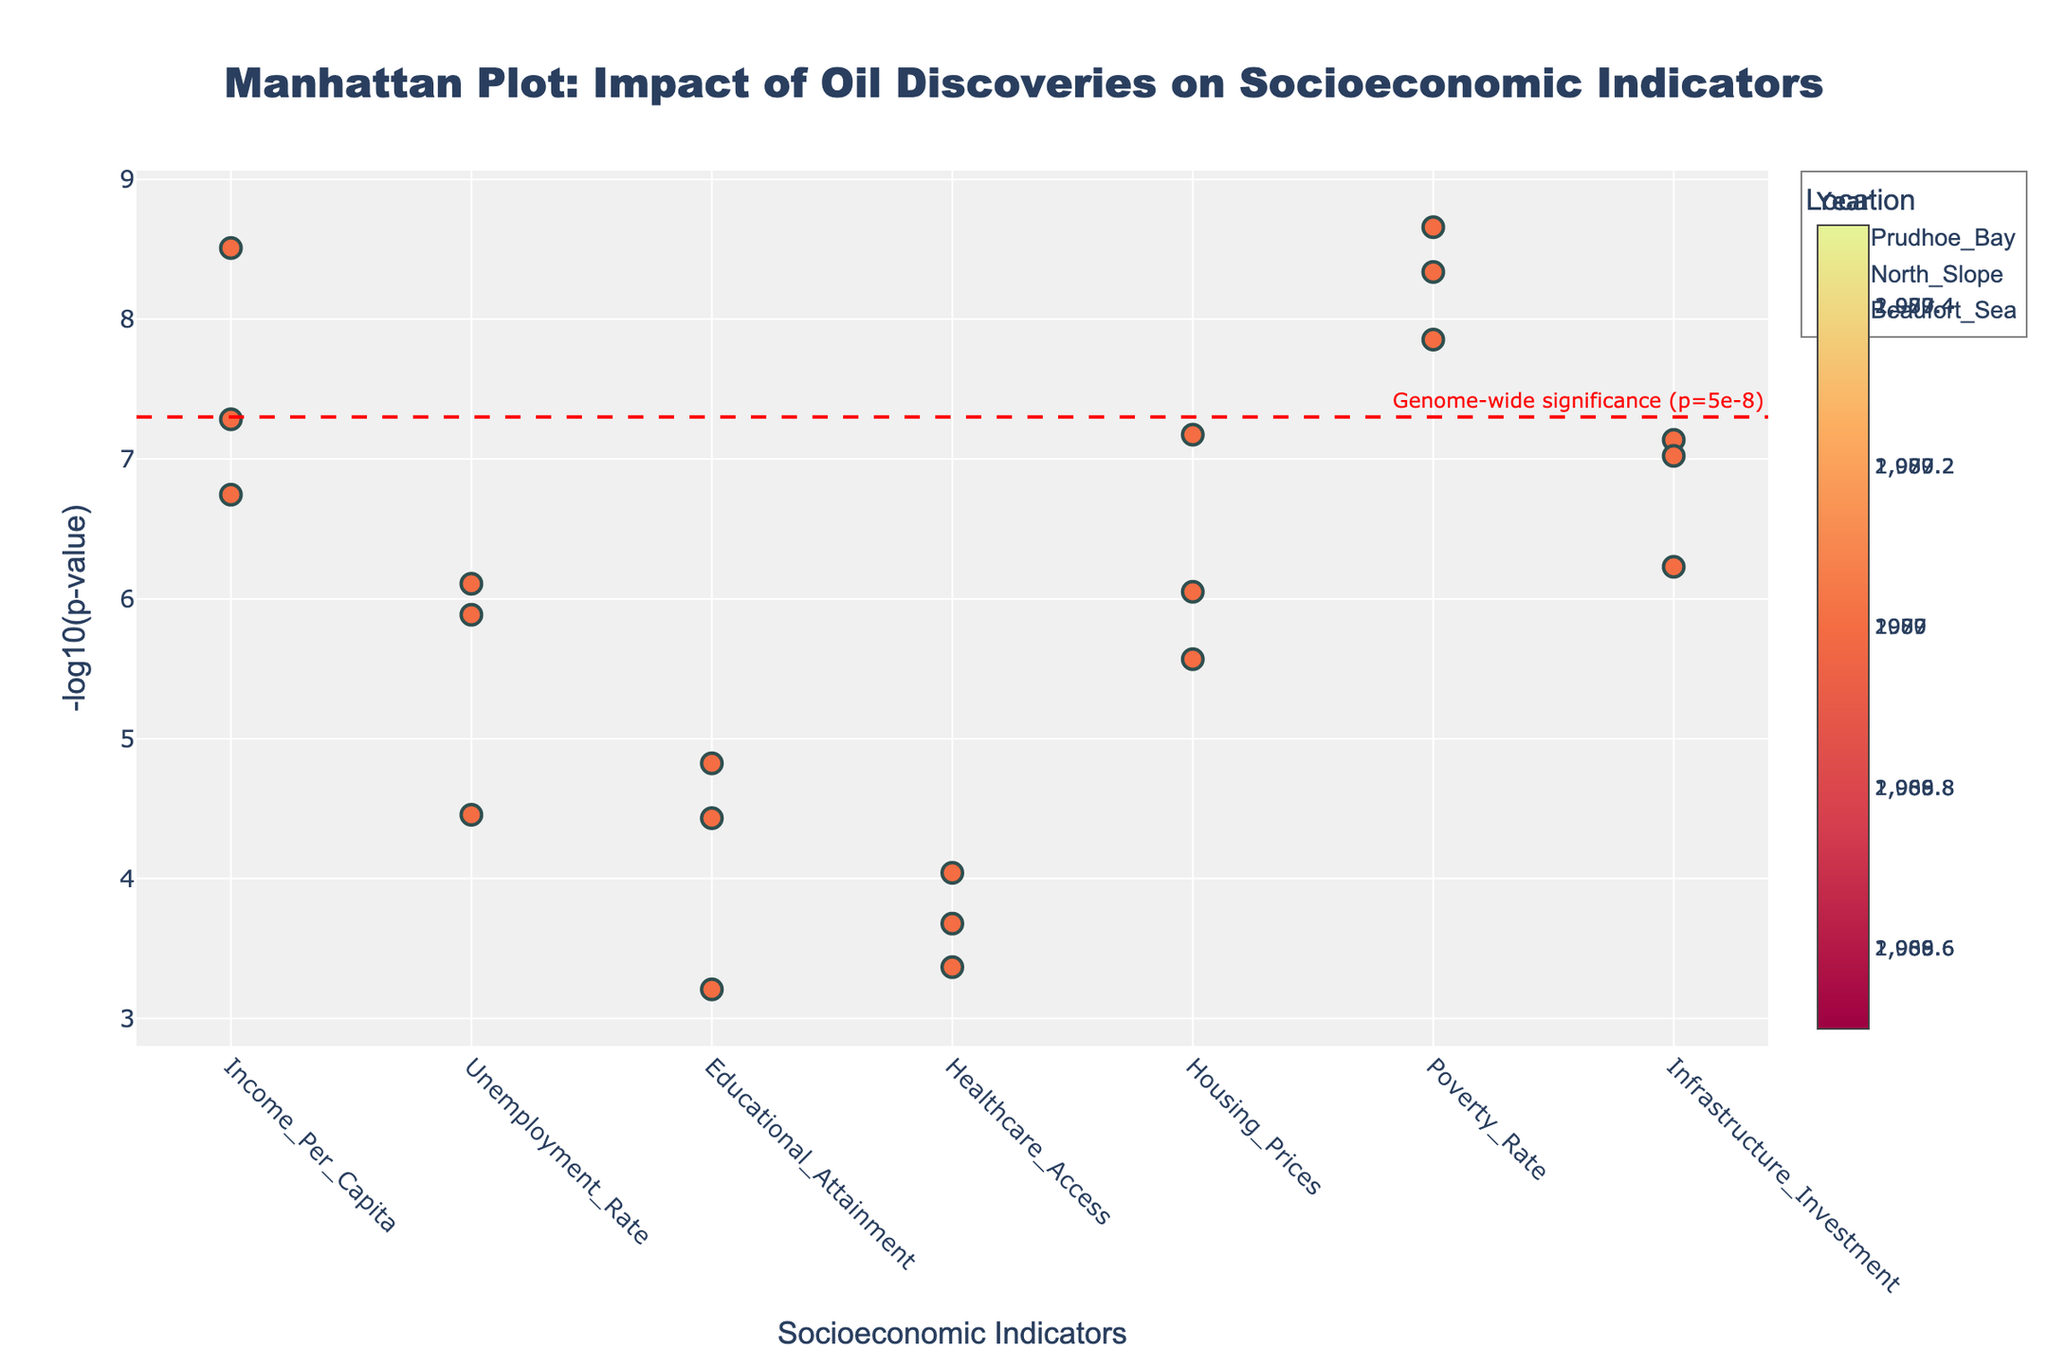What is the title of the plot? The title is displayed at the top of the plot. It reads "Manhattan Plot: Impact of Oil Discoveries on Socioeconomic Indicators."
Answer: Manhattan Plot: Impact of Oil Discoveries on Socioeconomic Indicators What are the x-axis and y-axis labels of the plot? The x-axis and y-axis labels are displayed along their respective axes. The x-axis is labeled "Socioeconomic Indicators," and the y-axis is labeled "-log10(p-value)."
Answer: Socioeconomic Indicators; -log10(p-value) What is the significance of the horizontal red dashed line in the plot? The horizontal red dashed line represents the genome-wide significance threshold, which is at -log10(p-value) for a p-value of 5e-8. This line is annotated with the text "Genome-wide significance (p=5e-8)."
Answer: Genome-wide significance (p=5e-8) Which socioeconomic indicator has the most significant p-value in 2007 at the Beaufort Sea? The most significant p-value corresponds to the highest y-value (-log10(p-value)) for Beaufort Sea in 2007. By examining the plot, we find that the indicator is "Poverty Rate."
Answer: Poverty Rate How do the p-values of "Income_Per_Capita" compare between 1970 in Prudhoe Bay and 1989 in North Slope? We need to compare the y-values (-log10(p-value)) for "Income_Per_Capita" in 1970 (Prudhoe Bay) and 1989 (North Slope). The y-value is higher in 1970, indicating a more significant p-value.
Answer: 1970 in Prudhoe Bay has a more significant p-value What year shows the highest -log10(p-value) across all indicators and locations? The highest -log10(p-value) across all indicators and locations corresponds to the highest point in the plot. This point is for "Poverty Rate" in 1970 in Prudhoe Bay.
Answer: 1970 Which location has the least significant p-value for "Educational_Attainment"? The least significant p-value for "Educational_Attainment" corresponds to the lowest -log10(p-value) for that indicator. By examining the plot, we find it is 1989 in North Slope.
Answer: North Slope in 1989 What is the difference in the -log10(p-value) of "Healthcare_Access" between 1970 in Prudhoe Bay and 2007 in Beaufort Sea? To find the difference, we calculate the -log10(p-value) for "Healthcare_Access" in 1970 in Prudhoe Bay and 2007 in Beaufort Sea, then subtract the smaller value from the larger one. From the plot, the values approximately are 3.7 and 3.37, respectively. The difference is 3.7 - 3.37 = 0.33.
Answer: 0.33 Which location and year combination has the closest p-value just above the genome-wide significance line for "Housing_Prices"? To find this, we look for the closest p-value just above the significance line for "Housing_Prices." By inspecting the plot, the point closest to the line is 1989 in North Slope.
Answer: North Slope in 1989 Which socioeconomic indicator shows a significant change in p-value between 1970 and 2007 in Prudhoe Bay and Beaufort Sea, respectively? By comparing the -log10(p-value) for indicators between 1970 in Prudhoe Bay and 2007 in Beaufort Sea, we identify "Income_Per_Capita" as showing a change from 7.28 to 8.51.
Answer: Income_Per_Capita 